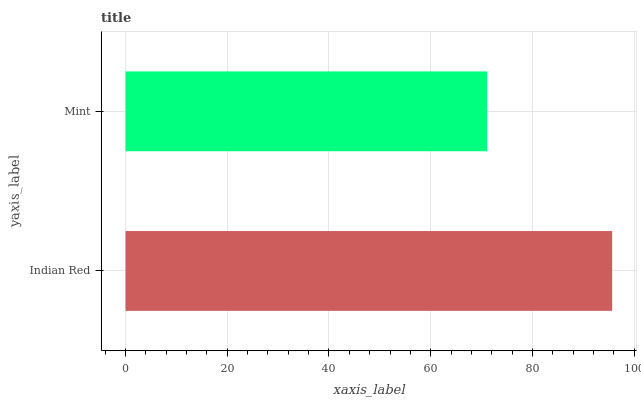Is Mint the minimum?
Answer yes or no. Yes. Is Indian Red the maximum?
Answer yes or no. Yes. Is Mint the maximum?
Answer yes or no. No. Is Indian Red greater than Mint?
Answer yes or no. Yes. Is Mint less than Indian Red?
Answer yes or no. Yes. Is Mint greater than Indian Red?
Answer yes or no. No. Is Indian Red less than Mint?
Answer yes or no. No. Is Indian Red the high median?
Answer yes or no. Yes. Is Mint the low median?
Answer yes or no. Yes. Is Mint the high median?
Answer yes or no. No. Is Indian Red the low median?
Answer yes or no. No. 